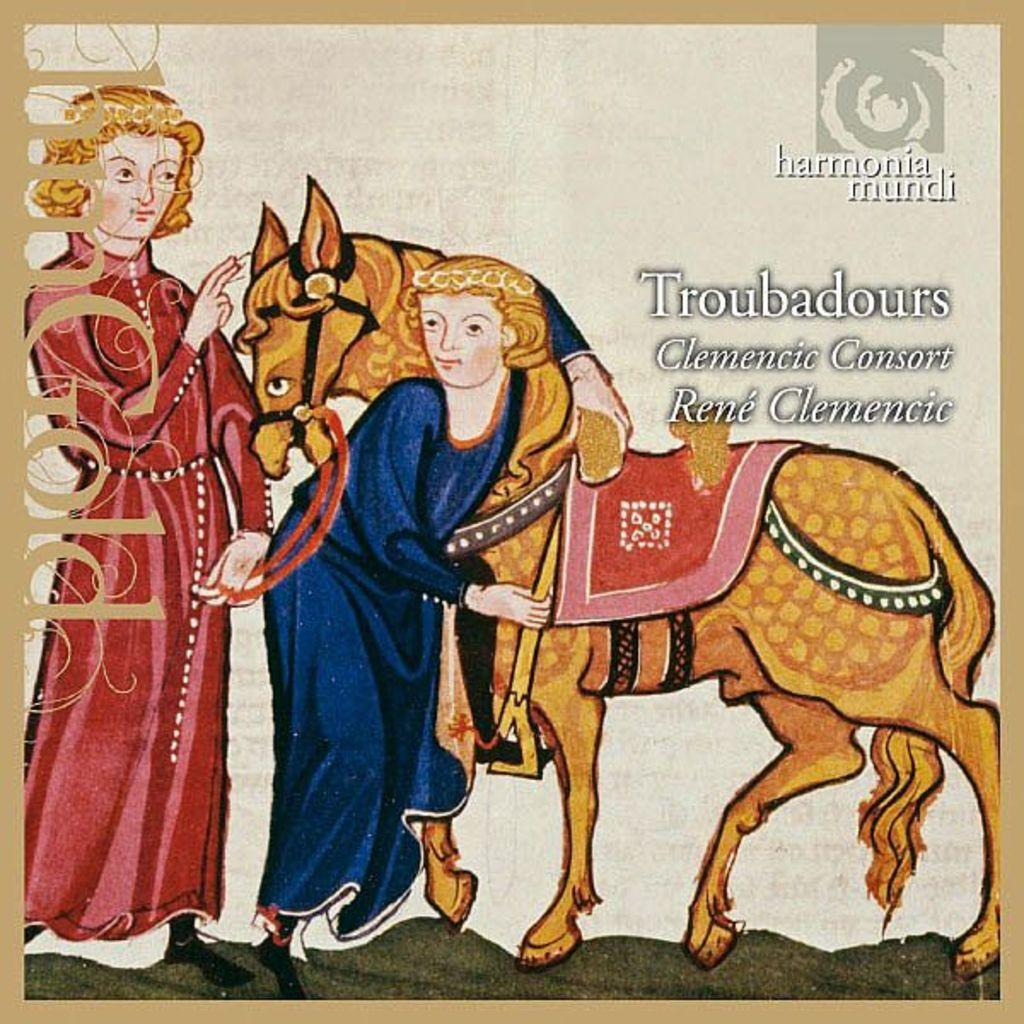What is the main subject of the image? The main subject of the image is a cover page. What can be found on the cover page? There is text on the cover page. What type of tooth is shown on the cover page? There is no tooth present on the cover page; it only contains text. 